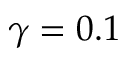Convert formula to latex. <formula><loc_0><loc_0><loc_500><loc_500>\gamma = 0 . 1</formula> 